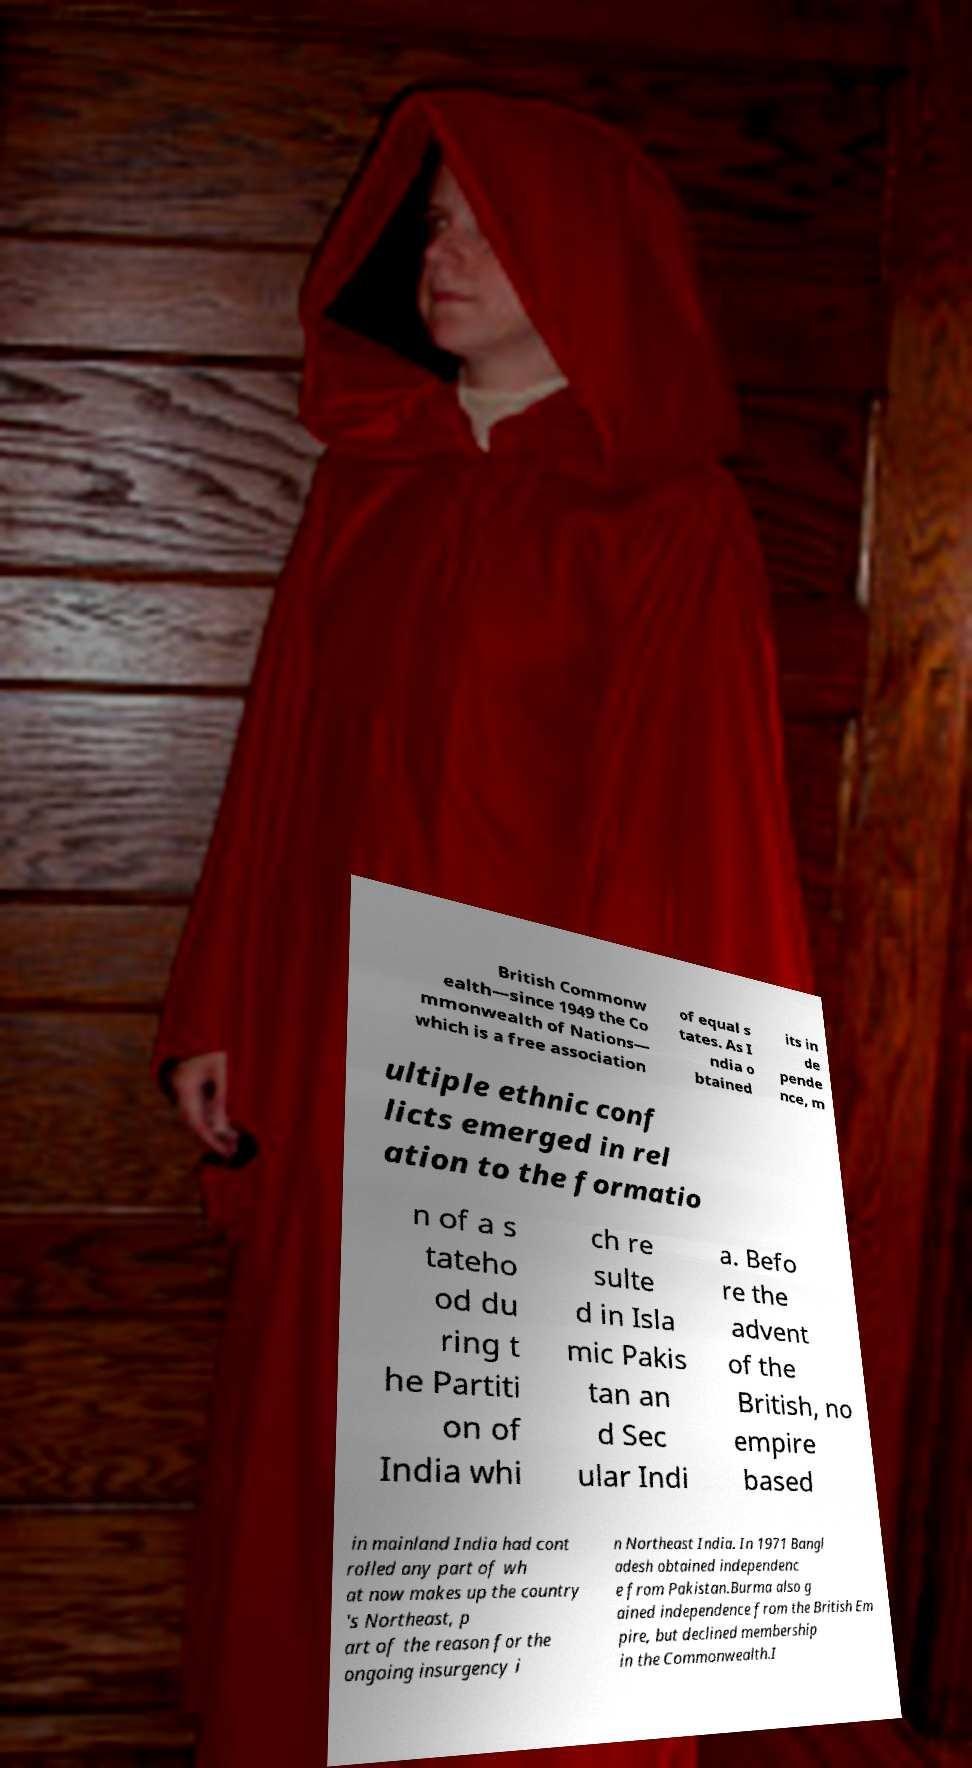I need the written content from this picture converted into text. Can you do that? British Commonw ealth—since 1949 the Co mmonwealth of Nations— which is a free association of equal s tates. As I ndia o btained its in de pende nce, m ultiple ethnic conf licts emerged in rel ation to the formatio n of a s tateho od du ring t he Partiti on of India whi ch re sulte d in Isla mic Pakis tan an d Sec ular Indi a. Befo re the advent of the British, no empire based in mainland India had cont rolled any part of wh at now makes up the country 's Northeast, p art of the reason for the ongoing insurgency i n Northeast India. In 1971 Bangl adesh obtained independenc e from Pakistan.Burma also g ained independence from the British Em pire, but declined membership in the Commonwealth.I 